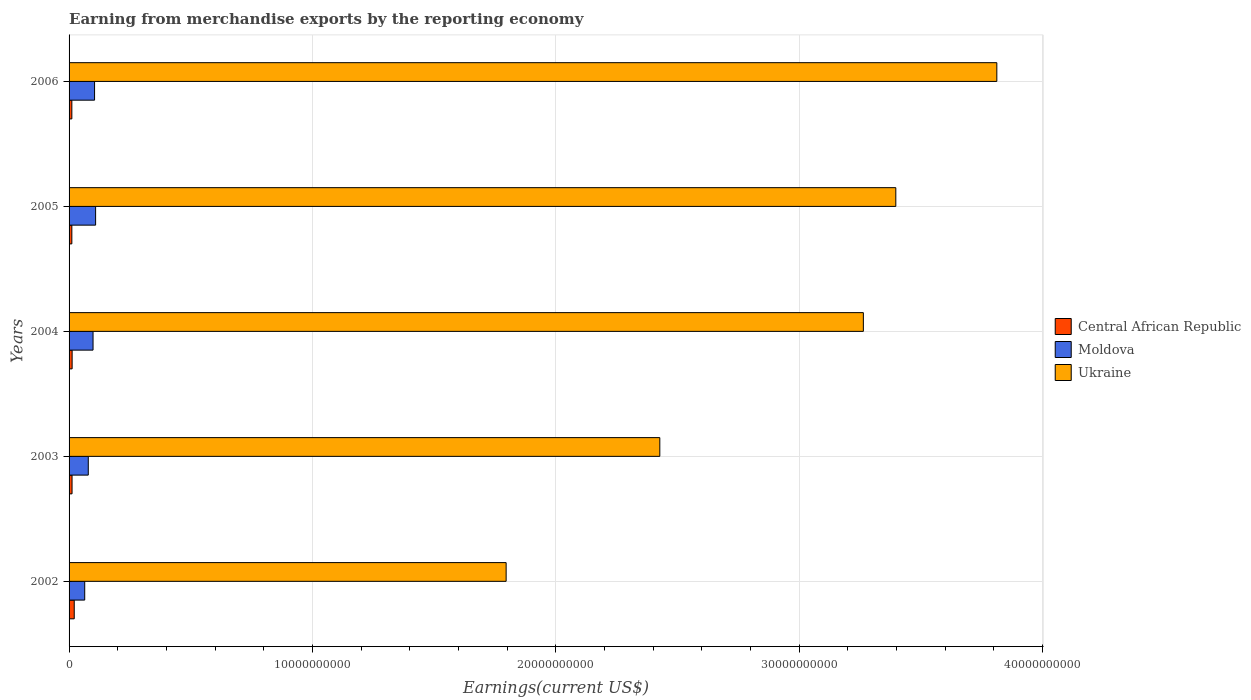How many groups of bars are there?
Your response must be concise. 5. Are the number of bars per tick equal to the number of legend labels?
Keep it short and to the point. Yes. How many bars are there on the 3rd tick from the top?
Make the answer very short. 3. What is the amount earned from merchandise exports in Central African Republic in 2005?
Offer a terse response. 1.14e+08. Across all years, what is the maximum amount earned from merchandise exports in Ukraine?
Ensure brevity in your answer.  3.81e+1. Across all years, what is the minimum amount earned from merchandise exports in Moldova?
Your response must be concise. 6.43e+08. In which year was the amount earned from merchandise exports in Ukraine maximum?
Provide a short and direct response. 2006. In which year was the amount earned from merchandise exports in Moldova minimum?
Offer a very short reply. 2002. What is the total amount earned from merchandise exports in Ukraine in the graph?
Provide a short and direct response. 1.47e+11. What is the difference between the amount earned from merchandise exports in Ukraine in 2002 and that in 2003?
Offer a terse response. -6.31e+09. What is the difference between the amount earned from merchandise exports in Ukraine in 2005 and the amount earned from merchandise exports in Moldova in 2002?
Keep it short and to the point. 3.33e+1. What is the average amount earned from merchandise exports in Central African Republic per year?
Offer a very short reply. 1.38e+08. In the year 2005, what is the difference between the amount earned from merchandise exports in Moldova and amount earned from merchandise exports in Ukraine?
Your response must be concise. -3.29e+1. In how many years, is the amount earned from merchandise exports in Ukraine greater than 28000000000 US$?
Your answer should be compact. 3. What is the ratio of the amount earned from merchandise exports in Ukraine in 2004 to that in 2006?
Ensure brevity in your answer.  0.86. What is the difference between the highest and the second highest amount earned from merchandise exports in Ukraine?
Your answer should be very brief. 4.15e+09. What is the difference between the highest and the lowest amount earned from merchandise exports in Moldova?
Keep it short and to the point. 4.47e+08. In how many years, is the amount earned from merchandise exports in Ukraine greater than the average amount earned from merchandise exports in Ukraine taken over all years?
Provide a succinct answer. 3. Is the sum of the amount earned from merchandise exports in Moldova in 2002 and 2005 greater than the maximum amount earned from merchandise exports in Ukraine across all years?
Your response must be concise. No. What does the 3rd bar from the top in 2002 represents?
Your answer should be very brief. Central African Republic. What does the 2nd bar from the bottom in 2006 represents?
Offer a very short reply. Moldova. How many bars are there?
Your answer should be very brief. 15. How many years are there in the graph?
Your answer should be compact. 5. What is the difference between two consecutive major ticks on the X-axis?
Provide a short and direct response. 1.00e+1. Are the values on the major ticks of X-axis written in scientific E-notation?
Give a very brief answer. No. How are the legend labels stacked?
Your answer should be compact. Vertical. What is the title of the graph?
Give a very brief answer. Earning from merchandise exports by the reporting economy. Does "Vietnam" appear as one of the legend labels in the graph?
Offer a terse response. No. What is the label or title of the X-axis?
Offer a very short reply. Earnings(current US$). What is the label or title of the Y-axis?
Your answer should be compact. Years. What is the Earnings(current US$) in Central African Republic in 2002?
Provide a short and direct response. 2.12e+08. What is the Earnings(current US$) of Moldova in 2002?
Ensure brevity in your answer.  6.43e+08. What is the Earnings(current US$) of Ukraine in 2002?
Your response must be concise. 1.80e+1. What is the Earnings(current US$) in Central African Republic in 2003?
Ensure brevity in your answer.  1.22e+08. What is the Earnings(current US$) in Moldova in 2003?
Make the answer very short. 7.90e+08. What is the Earnings(current US$) in Ukraine in 2003?
Keep it short and to the point. 2.43e+1. What is the Earnings(current US$) of Central African Republic in 2004?
Provide a short and direct response. 1.26e+08. What is the Earnings(current US$) in Moldova in 2004?
Offer a very short reply. 9.85e+08. What is the Earnings(current US$) in Ukraine in 2004?
Keep it short and to the point. 3.26e+1. What is the Earnings(current US$) of Central African Republic in 2005?
Keep it short and to the point. 1.14e+08. What is the Earnings(current US$) in Moldova in 2005?
Ensure brevity in your answer.  1.09e+09. What is the Earnings(current US$) in Ukraine in 2005?
Your answer should be very brief. 3.40e+1. What is the Earnings(current US$) of Central African Republic in 2006?
Provide a short and direct response. 1.14e+08. What is the Earnings(current US$) of Moldova in 2006?
Make the answer very short. 1.05e+09. What is the Earnings(current US$) in Ukraine in 2006?
Provide a succinct answer. 3.81e+1. Across all years, what is the maximum Earnings(current US$) of Central African Republic?
Give a very brief answer. 2.12e+08. Across all years, what is the maximum Earnings(current US$) of Moldova?
Provide a succinct answer. 1.09e+09. Across all years, what is the maximum Earnings(current US$) of Ukraine?
Give a very brief answer. 3.81e+1. Across all years, what is the minimum Earnings(current US$) of Central African Republic?
Your answer should be compact. 1.14e+08. Across all years, what is the minimum Earnings(current US$) of Moldova?
Offer a very short reply. 6.43e+08. Across all years, what is the minimum Earnings(current US$) of Ukraine?
Your answer should be compact. 1.80e+1. What is the total Earnings(current US$) of Central African Republic in the graph?
Give a very brief answer. 6.88e+08. What is the total Earnings(current US$) of Moldova in the graph?
Provide a short and direct response. 4.56e+09. What is the total Earnings(current US$) of Ukraine in the graph?
Provide a succinct answer. 1.47e+11. What is the difference between the Earnings(current US$) of Central African Republic in 2002 and that in 2003?
Ensure brevity in your answer.  8.99e+07. What is the difference between the Earnings(current US$) in Moldova in 2002 and that in 2003?
Provide a short and direct response. -1.47e+08. What is the difference between the Earnings(current US$) of Ukraine in 2002 and that in 2003?
Your response must be concise. -6.31e+09. What is the difference between the Earnings(current US$) in Central African Republic in 2002 and that in 2004?
Your answer should be very brief. 8.67e+07. What is the difference between the Earnings(current US$) of Moldova in 2002 and that in 2004?
Ensure brevity in your answer.  -3.42e+08. What is the difference between the Earnings(current US$) of Ukraine in 2002 and that in 2004?
Make the answer very short. -1.47e+1. What is the difference between the Earnings(current US$) in Central African Republic in 2002 and that in 2005?
Provide a succinct answer. 9.82e+07. What is the difference between the Earnings(current US$) in Moldova in 2002 and that in 2005?
Make the answer very short. -4.47e+08. What is the difference between the Earnings(current US$) of Ukraine in 2002 and that in 2005?
Ensure brevity in your answer.  -1.60e+1. What is the difference between the Earnings(current US$) in Central African Republic in 2002 and that in 2006?
Offer a very short reply. 9.87e+07. What is the difference between the Earnings(current US$) in Moldova in 2002 and that in 2006?
Provide a short and direct response. -4.04e+08. What is the difference between the Earnings(current US$) in Ukraine in 2002 and that in 2006?
Provide a succinct answer. -2.02e+1. What is the difference between the Earnings(current US$) of Central African Republic in 2003 and that in 2004?
Keep it short and to the point. -3.22e+06. What is the difference between the Earnings(current US$) in Moldova in 2003 and that in 2004?
Offer a terse response. -1.95e+08. What is the difference between the Earnings(current US$) of Ukraine in 2003 and that in 2004?
Keep it short and to the point. -8.36e+09. What is the difference between the Earnings(current US$) of Central African Republic in 2003 and that in 2005?
Your answer should be very brief. 8.32e+06. What is the difference between the Earnings(current US$) of Moldova in 2003 and that in 2005?
Provide a succinct answer. -3.01e+08. What is the difference between the Earnings(current US$) of Ukraine in 2003 and that in 2005?
Provide a short and direct response. -9.70e+09. What is the difference between the Earnings(current US$) of Central African Republic in 2003 and that in 2006?
Give a very brief answer. 8.81e+06. What is the difference between the Earnings(current US$) of Moldova in 2003 and that in 2006?
Make the answer very short. -2.58e+08. What is the difference between the Earnings(current US$) in Ukraine in 2003 and that in 2006?
Provide a succinct answer. -1.38e+1. What is the difference between the Earnings(current US$) of Central African Republic in 2004 and that in 2005?
Provide a short and direct response. 1.15e+07. What is the difference between the Earnings(current US$) in Moldova in 2004 and that in 2005?
Keep it short and to the point. -1.06e+08. What is the difference between the Earnings(current US$) in Ukraine in 2004 and that in 2005?
Make the answer very short. -1.33e+09. What is the difference between the Earnings(current US$) in Central African Republic in 2004 and that in 2006?
Your answer should be compact. 1.20e+07. What is the difference between the Earnings(current US$) of Moldova in 2004 and that in 2006?
Make the answer very short. -6.26e+07. What is the difference between the Earnings(current US$) in Ukraine in 2004 and that in 2006?
Provide a succinct answer. -5.48e+09. What is the difference between the Earnings(current US$) in Central African Republic in 2005 and that in 2006?
Your answer should be compact. 4.88e+05. What is the difference between the Earnings(current US$) of Moldova in 2005 and that in 2006?
Keep it short and to the point. 4.30e+07. What is the difference between the Earnings(current US$) of Ukraine in 2005 and that in 2006?
Your response must be concise. -4.15e+09. What is the difference between the Earnings(current US$) of Central African Republic in 2002 and the Earnings(current US$) of Moldova in 2003?
Your answer should be very brief. -5.77e+08. What is the difference between the Earnings(current US$) of Central African Republic in 2002 and the Earnings(current US$) of Ukraine in 2003?
Offer a terse response. -2.41e+1. What is the difference between the Earnings(current US$) in Moldova in 2002 and the Earnings(current US$) in Ukraine in 2003?
Provide a short and direct response. -2.36e+1. What is the difference between the Earnings(current US$) in Central African Republic in 2002 and the Earnings(current US$) in Moldova in 2004?
Offer a very short reply. -7.72e+08. What is the difference between the Earnings(current US$) in Central African Republic in 2002 and the Earnings(current US$) in Ukraine in 2004?
Provide a short and direct response. -3.24e+1. What is the difference between the Earnings(current US$) of Moldova in 2002 and the Earnings(current US$) of Ukraine in 2004?
Your response must be concise. -3.20e+1. What is the difference between the Earnings(current US$) of Central African Republic in 2002 and the Earnings(current US$) of Moldova in 2005?
Provide a succinct answer. -8.78e+08. What is the difference between the Earnings(current US$) of Central African Republic in 2002 and the Earnings(current US$) of Ukraine in 2005?
Offer a terse response. -3.38e+1. What is the difference between the Earnings(current US$) of Moldova in 2002 and the Earnings(current US$) of Ukraine in 2005?
Provide a succinct answer. -3.33e+1. What is the difference between the Earnings(current US$) in Central African Republic in 2002 and the Earnings(current US$) in Moldova in 2006?
Make the answer very short. -8.35e+08. What is the difference between the Earnings(current US$) of Central African Republic in 2002 and the Earnings(current US$) of Ukraine in 2006?
Your answer should be very brief. -3.79e+1. What is the difference between the Earnings(current US$) in Moldova in 2002 and the Earnings(current US$) in Ukraine in 2006?
Give a very brief answer. -3.75e+1. What is the difference between the Earnings(current US$) in Central African Republic in 2003 and the Earnings(current US$) in Moldova in 2004?
Keep it short and to the point. -8.62e+08. What is the difference between the Earnings(current US$) in Central African Republic in 2003 and the Earnings(current US$) in Ukraine in 2004?
Offer a terse response. -3.25e+1. What is the difference between the Earnings(current US$) in Moldova in 2003 and the Earnings(current US$) in Ukraine in 2004?
Offer a very short reply. -3.18e+1. What is the difference between the Earnings(current US$) of Central African Republic in 2003 and the Earnings(current US$) of Moldova in 2005?
Offer a terse response. -9.68e+08. What is the difference between the Earnings(current US$) in Central African Republic in 2003 and the Earnings(current US$) in Ukraine in 2005?
Offer a very short reply. -3.38e+1. What is the difference between the Earnings(current US$) of Moldova in 2003 and the Earnings(current US$) of Ukraine in 2005?
Your answer should be very brief. -3.32e+1. What is the difference between the Earnings(current US$) in Central African Republic in 2003 and the Earnings(current US$) in Moldova in 2006?
Offer a terse response. -9.25e+08. What is the difference between the Earnings(current US$) in Central African Republic in 2003 and the Earnings(current US$) in Ukraine in 2006?
Your answer should be very brief. -3.80e+1. What is the difference between the Earnings(current US$) of Moldova in 2003 and the Earnings(current US$) of Ukraine in 2006?
Ensure brevity in your answer.  -3.73e+1. What is the difference between the Earnings(current US$) of Central African Republic in 2004 and the Earnings(current US$) of Moldova in 2005?
Your answer should be very brief. -9.65e+08. What is the difference between the Earnings(current US$) of Central African Republic in 2004 and the Earnings(current US$) of Ukraine in 2005?
Provide a short and direct response. -3.38e+1. What is the difference between the Earnings(current US$) in Moldova in 2004 and the Earnings(current US$) in Ukraine in 2005?
Make the answer very short. -3.30e+1. What is the difference between the Earnings(current US$) of Central African Republic in 2004 and the Earnings(current US$) of Moldova in 2006?
Your answer should be very brief. -9.22e+08. What is the difference between the Earnings(current US$) of Central African Republic in 2004 and the Earnings(current US$) of Ukraine in 2006?
Ensure brevity in your answer.  -3.80e+1. What is the difference between the Earnings(current US$) in Moldova in 2004 and the Earnings(current US$) in Ukraine in 2006?
Your answer should be very brief. -3.71e+1. What is the difference between the Earnings(current US$) of Central African Republic in 2005 and the Earnings(current US$) of Moldova in 2006?
Your answer should be very brief. -9.33e+08. What is the difference between the Earnings(current US$) of Central African Republic in 2005 and the Earnings(current US$) of Ukraine in 2006?
Ensure brevity in your answer.  -3.80e+1. What is the difference between the Earnings(current US$) of Moldova in 2005 and the Earnings(current US$) of Ukraine in 2006?
Offer a terse response. -3.70e+1. What is the average Earnings(current US$) in Central African Republic per year?
Provide a succinct answer. 1.38e+08. What is the average Earnings(current US$) in Moldova per year?
Ensure brevity in your answer.  9.11e+08. What is the average Earnings(current US$) in Ukraine per year?
Provide a succinct answer. 2.94e+1. In the year 2002, what is the difference between the Earnings(current US$) of Central African Republic and Earnings(current US$) of Moldova?
Offer a very short reply. -4.31e+08. In the year 2002, what is the difference between the Earnings(current US$) in Central African Republic and Earnings(current US$) in Ukraine?
Make the answer very short. -1.77e+1. In the year 2002, what is the difference between the Earnings(current US$) in Moldova and Earnings(current US$) in Ukraine?
Keep it short and to the point. -1.73e+1. In the year 2003, what is the difference between the Earnings(current US$) of Central African Republic and Earnings(current US$) of Moldova?
Make the answer very short. -6.67e+08. In the year 2003, what is the difference between the Earnings(current US$) in Central African Republic and Earnings(current US$) in Ukraine?
Keep it short and to the point. -2.41e+1. In the year 2003, what is the difference between the Earnings(current US$) of Moldova and Earnings(current US$) of Ukraine?
Your response must be concise. -2.35e+1. In the year 2004, what is the difference between the Earnings(current US$) in Central African Republic and Earnings(current US$) in Moldova?
Your response must be concise. -8.59e+08. In the year 2004, what is the difference between the Earnings(current US$) of Central African Republic and Earnings(current US$) of Ukraine?
Keep it short and to the point. -3.25e+1. In the year 2004, what is the difference between the Earnings(current US$) of Moldova and Earnings(current US$) of Ukraine?
Your answer should be very brief. -3.16e+1. In the year 2005, what is the difference between the Earnings(current US$) in Central African Republic and Earnings(current US$) in Moldova?
Provide a short and direct response. -9.76e+08. In the year 2005, what is the difference between the Earnings(current US$) in Central African Republic and Earnings(current US$) in Ukraine?
Make the answer very short. -3.39e+1. In the year 2005, what is the difference between the Earnings(current US$) of Moldova and Earnings(current US$) of Ukraine?
Provide a short and direct response. -3.29e+1. In the year 2006, what is the difference between the Earnings(current US$) of Central African Republic and Earnings(current US$) of Moldova?
Your answer should be very brief. -9.34e+08. In the year 2006, what is the difference between the Earnings(current US$) in Central African Republic and Earnings(current US$) in Ukraine?
Ensure brevity in your answer.  -3.80e+1. In the year 2006, what is the difference between the Earnings(current US$) in Moldova and Earnings(current US$) in Ukraine?
Provide a succinct answer. -3.71e+1. What is the ratio of the Earnings(current US$) of Central African Republic in 2002 to that in 2003?
Provide a short and direct response. 1.73. What is the ratio of the Earnings(current US$) in Moldova in 2002 to that in 2003?
Make the answer very short. 0.81. What is the ratio of the Earnings(current US$) in Ukraine in 2002 to that in 2003?
Ensure brevity in your answer.  0.74. What is the ratio of the Earnings(current US$) of Central African Republic in 2002 to that in 2004?
Make the answer very short. 1.69. What is the ratio of the Earnings(current US$) of Moldova in 2002 to that in 2004?
Offer a terse response. 0.65. What is the ratio of the Earnings(current US$) in Ukraine in 2002 to that in 2004?
Your answer should be very brief. 0.55. What is the ratio of the Earnings(current US$) of Central African Republic in 2002 to that in 2005?
Your response must be concise. 1.86. What is the ratio of the Earnings(current US$) in Moldova in 2002 to that in 2005?
Your response must be concise. 0.59. What is the ratio of the Earnings(current US$) of Ukraine in 2002 to that in 2005?
Keep it short and to the point. 0.53. What is the ratio of the Earnings(current US$) of Central African Republic in 2002 to that in 2006?
Your response must be concise. 1.87. What is the ratio of the Earnings(current US$) in Moldova in 2002 to that in 2006?
Offer a very short reply. 0.61. What is the ratio of the Earnings(current US$) of Ukraine in 2002 to that in 2006?
Keep it short and to the point. 0.47. What is the ratio of the Earnings(current US$) in Central African Republic in 2003 to that in 2004?
Provide a short and direct response. 0.97. What is the ratio of the Earnings(current US$) in Moldova in 2003 to that in 2004?
Ensure brevity in your answer.  0.8. What is the ratio of the Earnings(current US$) of Ukraine in 2003 to that in 2004?
Provide a succinct answer. 0.74. What is the ratio of the Earnings(current US$) of Central African Republic in 2003 to that in 2005?
Ensure brevity in your answer.  1.07. What is the ratio of the Earnings(current US$) of Moldova in 2003 to that in 2005?
Offer a very short reply. 0.72. What is the ratio of the Earnings(current US$) of Ukraine in 2003 to that in 2005?
Offer a terse response. 0.71. What is the ratio of the Earnings(current US$) in Central African Republic in 2003 to that in 2006?
Ensure brevity in your answer.  1.08. What is the ratio of the Earnings(current US$) of Moldova in 2003 to that in 2006?
Provide a short and direct response. 0.75. What is the ratio of the Earnings(current US$) in Ukraine in 2003 to that in 2006?
Provide a succinct answer. 0.64. What is the ratio of the Earnings(current US$) of Central African Republic in 2004 to that in 2005?
Offer a very short reply. 1.1. What is the ratio of the Earnings(current US$) of Moldova in 2004 to that in 2005?
Provide a succinct answer. 0.9. What is the ratio of the Earnings(current US$) of Ukraine in 2004 to that in 2005?
Provide a succinct answer. 0.96. What is the ratio of the Earnings(current US$) of Central African Republic in 2004 to that in 2006?
Provide a succinct answer. 1.11. What is the ratio of the Earnings(current US$) in Moldova in 2004 to that in 2006?
Give a very brief answer. 0.94. What is the ratio of the Earnings(current US$) of Ukraine in 2004 to that in 2006?
Offer a terse response. 0.86. What is the ratio of the Earnings(current US$) of Central African Republic in 2005 to that in 2006?
Make the answer very short. 1. What is the ratio of the Earnings(current US$) of Moldova in 2005 to that in 2006?
Provide a succinct answer. 1.04. What is the ratio of the Earnings(current US$) of Ukraine in 2005 to that in 2006?
Offer a terse response. 0.89. What is the difference between the highest and the second highest Earnings(current US$) in Central African Republic?
Provide a short and direct response. 8.67e+07. What is the difference between the highest and the second highest Earnings(current US$) in Moldova?
Give a very brief answer. 4.30e+07. What is the difference between the highest and the second highest Earnings(current US$) of Ukraine?
Keep it short and to the point. 4.15e+09. What is the difference between the highest and the lowest Earnings(current US$) in Central African Republic?
Your answer should be compact. 9.87e+07. What is the difference between the highest and the lowest Earnings(current US$) in Moldova?
Your answer should be very brief. 4.47e+08. What is the difference between the highest and the lowest Earnings(current US$) in Ukraine?
Your answer should be very brief. 2.02e+1. 